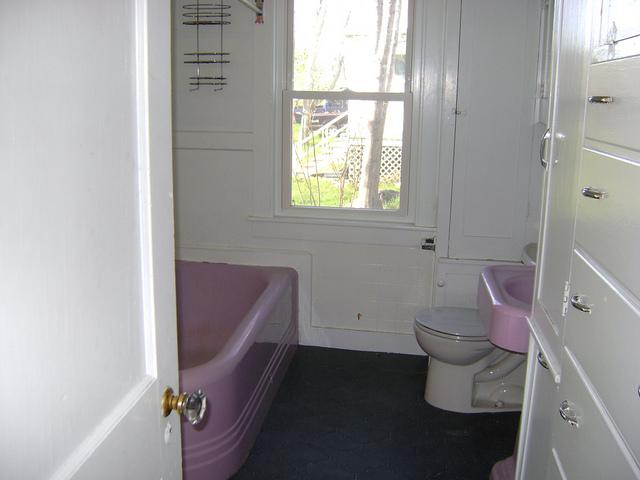Does the toilet match the tub and sink?
Keep it brief. No. Is there a sink in this room?
Keep it brief. Yes. Would someone be able to watch you change from the outside?
Short answer required. Yes. 